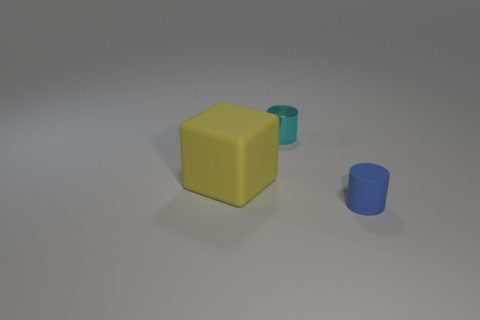There is a object in front of the cube; is its size the same as the rubber object behind the tiny blue matte cylinder?
Give a very brief answer. No. What number of other things are the same size as the yellow block?
Make the answer very short. 0. There is a matte thing to the left of the metallic cylinder; what number of small things are in front of it?
Provide a short and direct response. 1. Is the number of blue things on the left side of the blue rubber object less than the number of cyan cylinders?
Your response must be concise. Yes. What shape is the tiny thing on the left side of the matte thing right of the cylinder that is on the left side of the blue matte cylinder?
Provide a short and direct response. Cylinder. Do the yellow matte object and the metal object have the same shape?
Your response must be concise. No. What number of other things are there of the same shape as the large rubber thing?
Your response must be concise. 0. There is another thing that is the same size as the cyan object; what color is it?
Keep it short and to the point. Blue. Are there an equal number of big cubes in front of the yellow rubber thing and small blue matte things?
Offer a terse response. No. What is the shape of the object that is to the right of the cube and in front of the tiny cyan metallic thing?
Provide a short and direct response. Cylinder. 